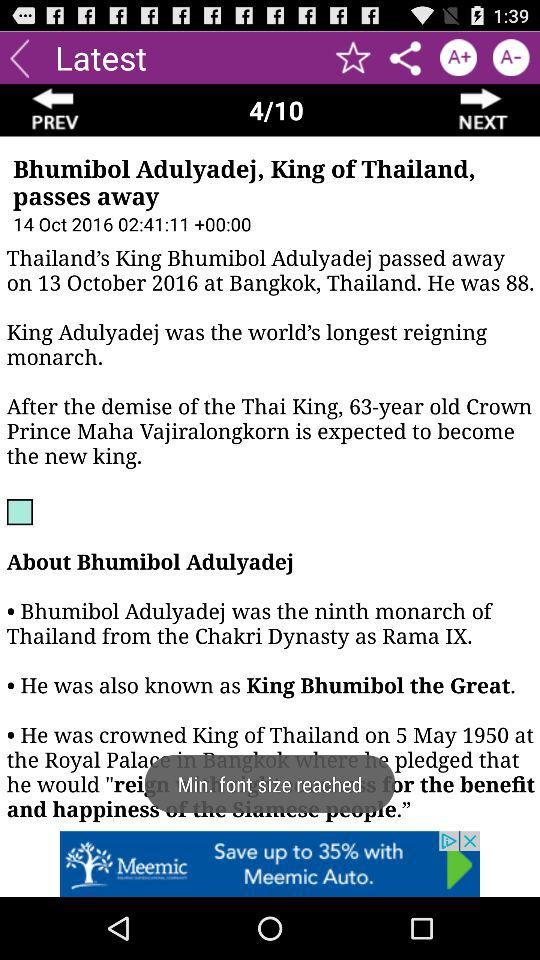What is the current page number? The current page number is 4. 